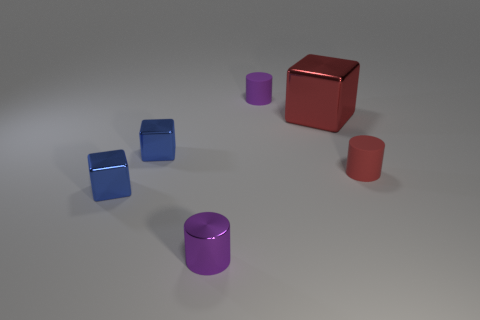Add 2 red cubes. How many objects exist? 8 Add 3 blue metallic cubes. How many blue metallic cubes are left? 5 Add 2 purple matte cylinders. How many purple matte cylinders exist? 3 Subtract 1 red cubes. How many objects are left? 5 Subtract all tiny cyan cylinders. Subtract all tiny metallic cylinders. How many objects are left? 5 